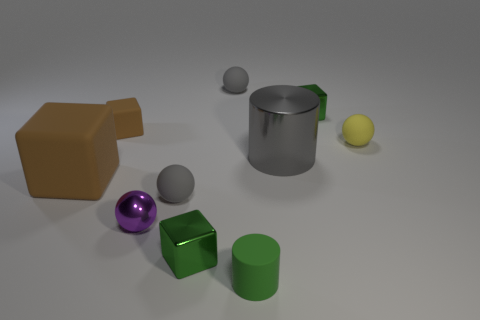Subtract all big brown cubes. How many cubes are left? 3 Subtract all spheres. How many objects are left? 6 Subtract 4 blocks. How many blocks are left? 0 Subtract all yellow spheres. How many spheres are left? 3 Subtract all blue cylinders. Subtract all green blocks. How many cylinders are left? 2 Subtract all brown balls. How many brown blocks are left? 2 Subtract all gray shiny things. Subtract all green objects. How many objects are left? 6 Add 9 green cylinders. How many green cylinders are left? 10 Add 6 tiny brown rubber objects. How many tiny brown rubber objects exist? 7 Subtract 0 gray blocks. How many objects are left? 10 